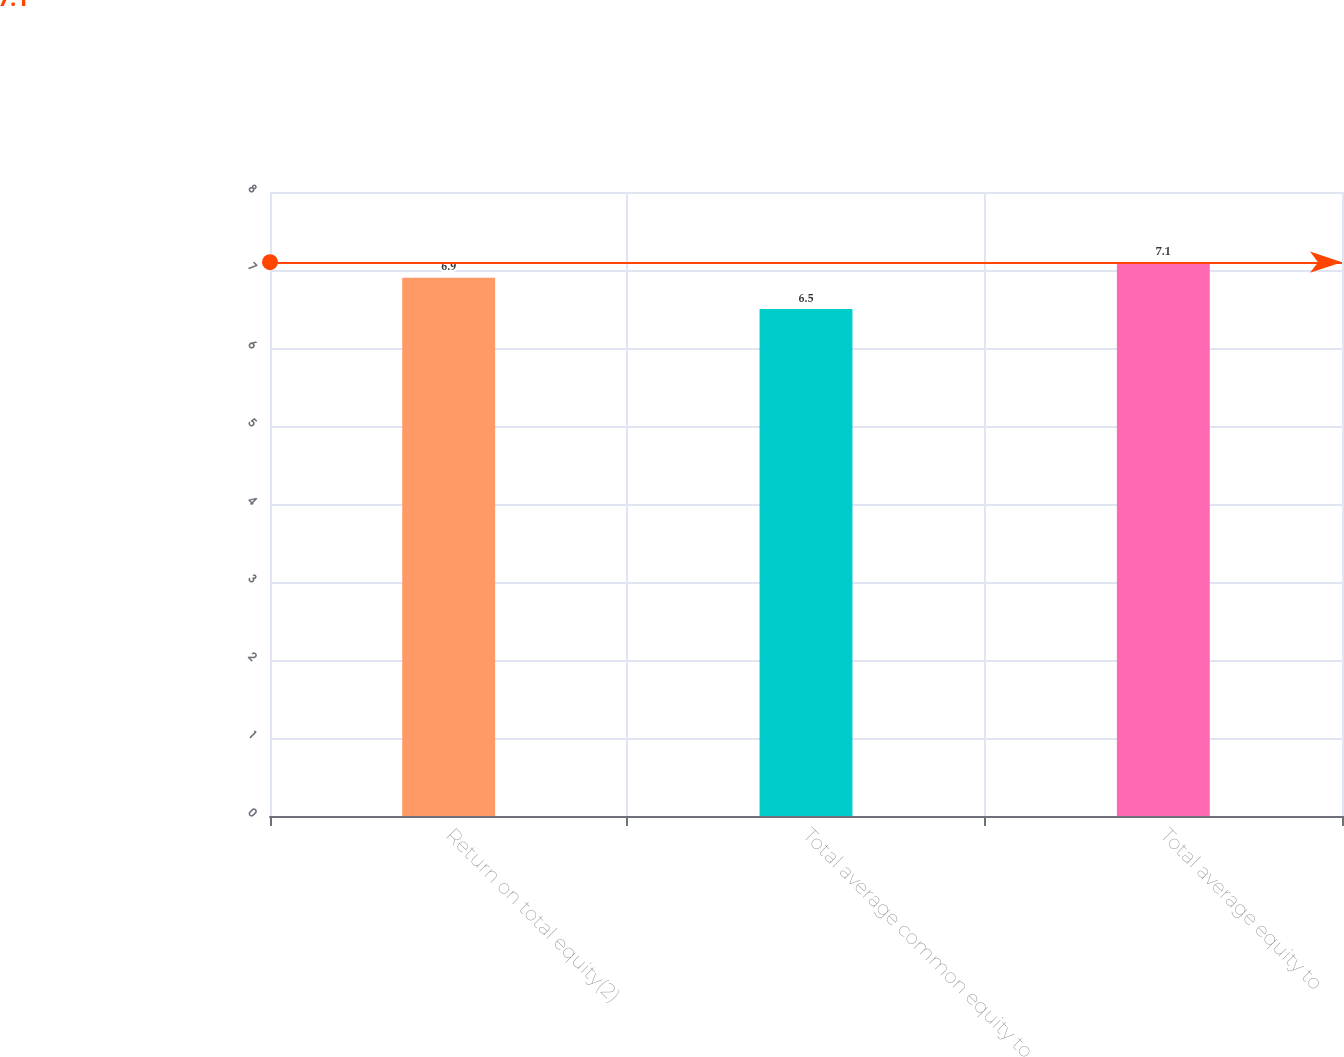Convert chart. <chart><loc_0><loc_0><loc_500><loc_500><bar_chart><fcel>Return on total equity(2)<fcel>Total average common equity to<fcel>Total average equity to<nl><fcel>6.9<fcel>6.5<fcel>7.1<nl></chart> 